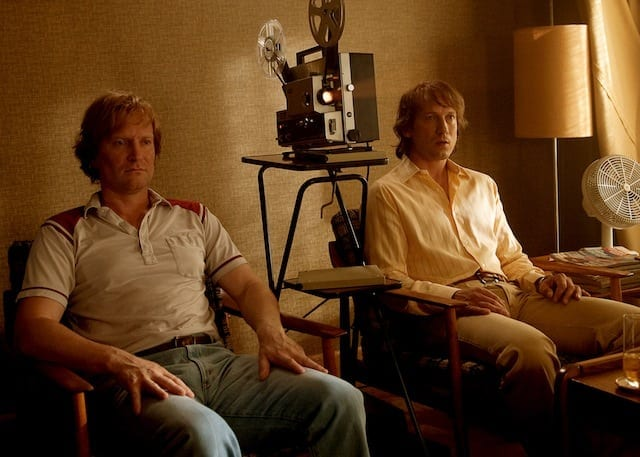Describe the setting and atmosphere of this image. This image depicts a cozy, retro setting with two individuals appearing to have a thoughtful moment. The warm, muted tones create an intimate atmosphere, accentuated by the presence of a vintage film projector and a soft-lit lamp. The men are casually dressed, with one in a striped shirt and jeans, and the other in a yellow shirt and similar jeans, suggesting a relaxed, possibly informal gathering. What emotions do you think are being conveyed by the people in this image? The individuals in the image seem to convey a mixture of contemplation and calmness. Their relaxed postures and neutral expressions hint at a moment of reflection or deep thought. The setting, with its subdued lighting and nostalgic elements, adds to a sense of introspection and tranquility. 